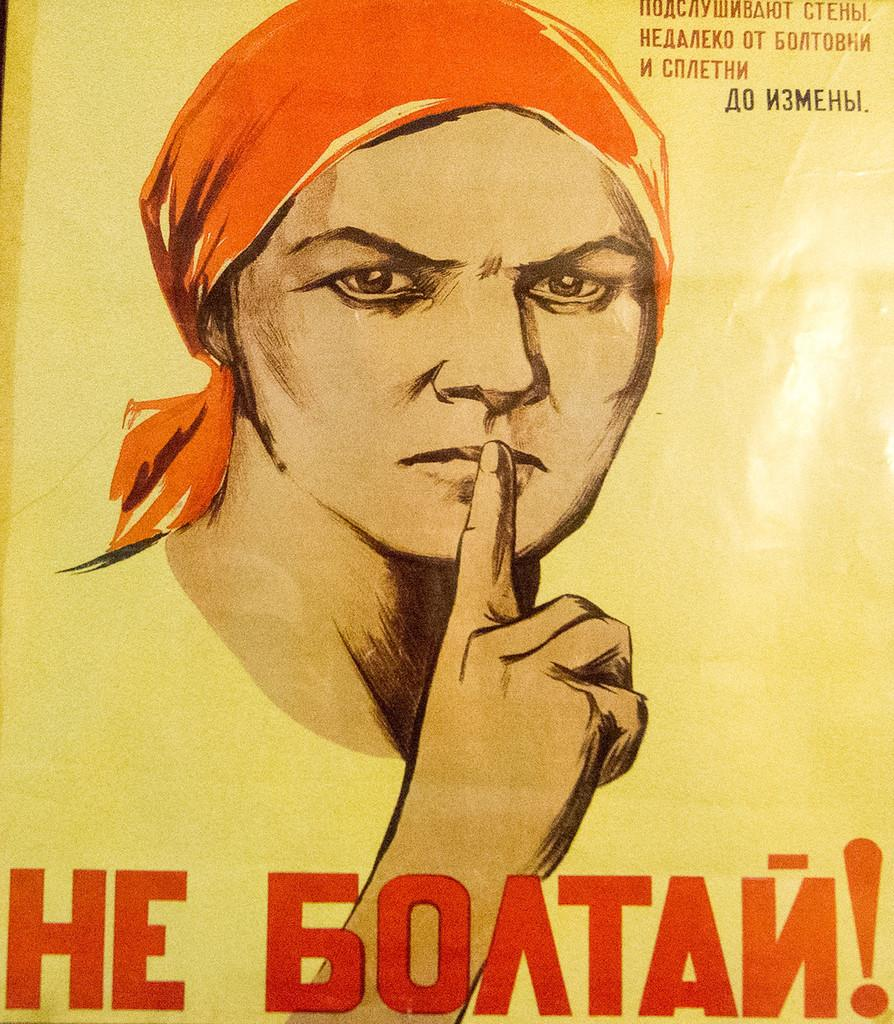What is the main subject of the image? There is a depiction of a human face in the image. Are there any words or letters in the image? Yes, there is writing in the image. What color is the background of the image? The background has a yellow color. How does the yam contribute to the image? There is no yam present in the image. What action does the stop sign perform in the image? There is no stop sign present in the image. 